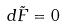Convert formula to latex. <formula><loc_0><loc_0><loc_500><loc_500>d { \tilde { F } } = 0</formula> 